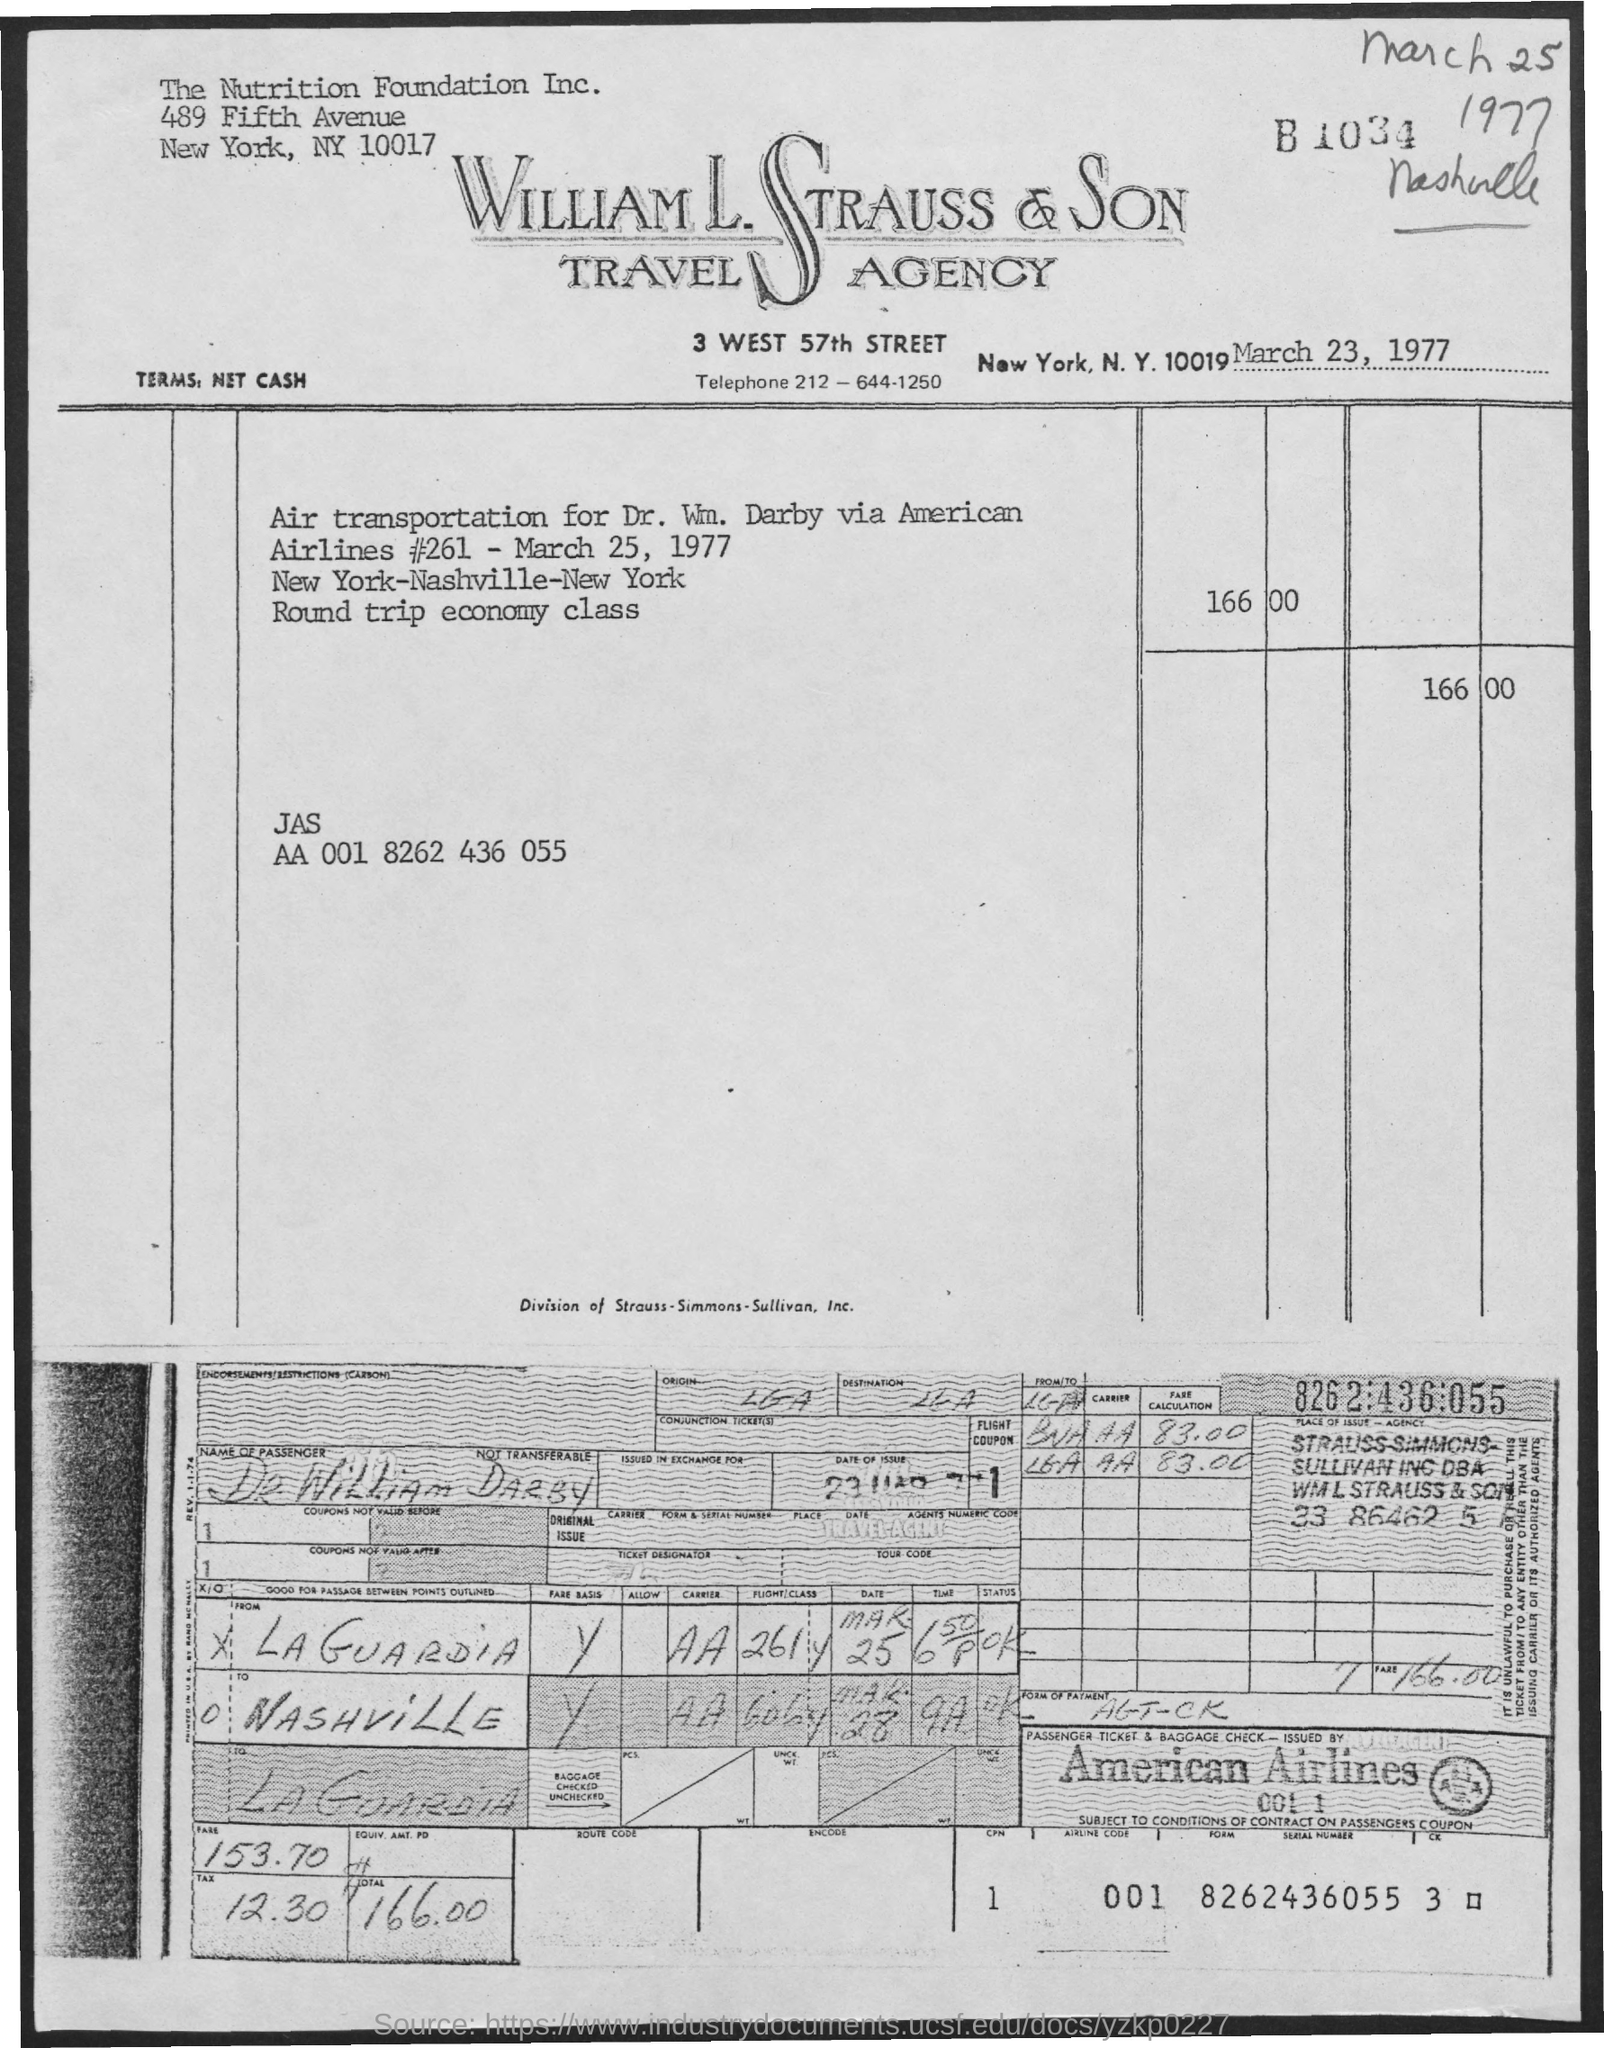List a handful of essential elements in this visual. The name of the travel agency is William L. Strauss & Son Travel Agency. Dr. William Darby has traveled. 